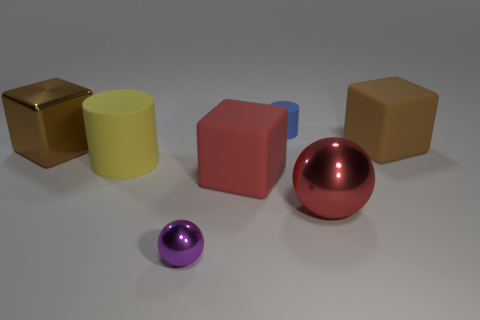Subtract all brown cubes. How many cubes are left? 1 Subtract all red cubes. How many cubes are left? 2 Add 1 metallic balls. How many objects exist? 8 Subtract 1 cylinders. How many cylinders are left? 1 Subtract all large brown cylinders. Subtract all big red spheres. How many objects are left? 6 Add 1 brown shiny things. How many brown shiny things are left? 2 Add 6 green matte objects. How many green matte objects exist? 6 Subtract 0 cyan cubes. How many objects are left? 7 Subtract all cylinders. How many objects are left? 5 Subtract all purple blocks. Subtract all brown spheres. How many blocks are left? 3 